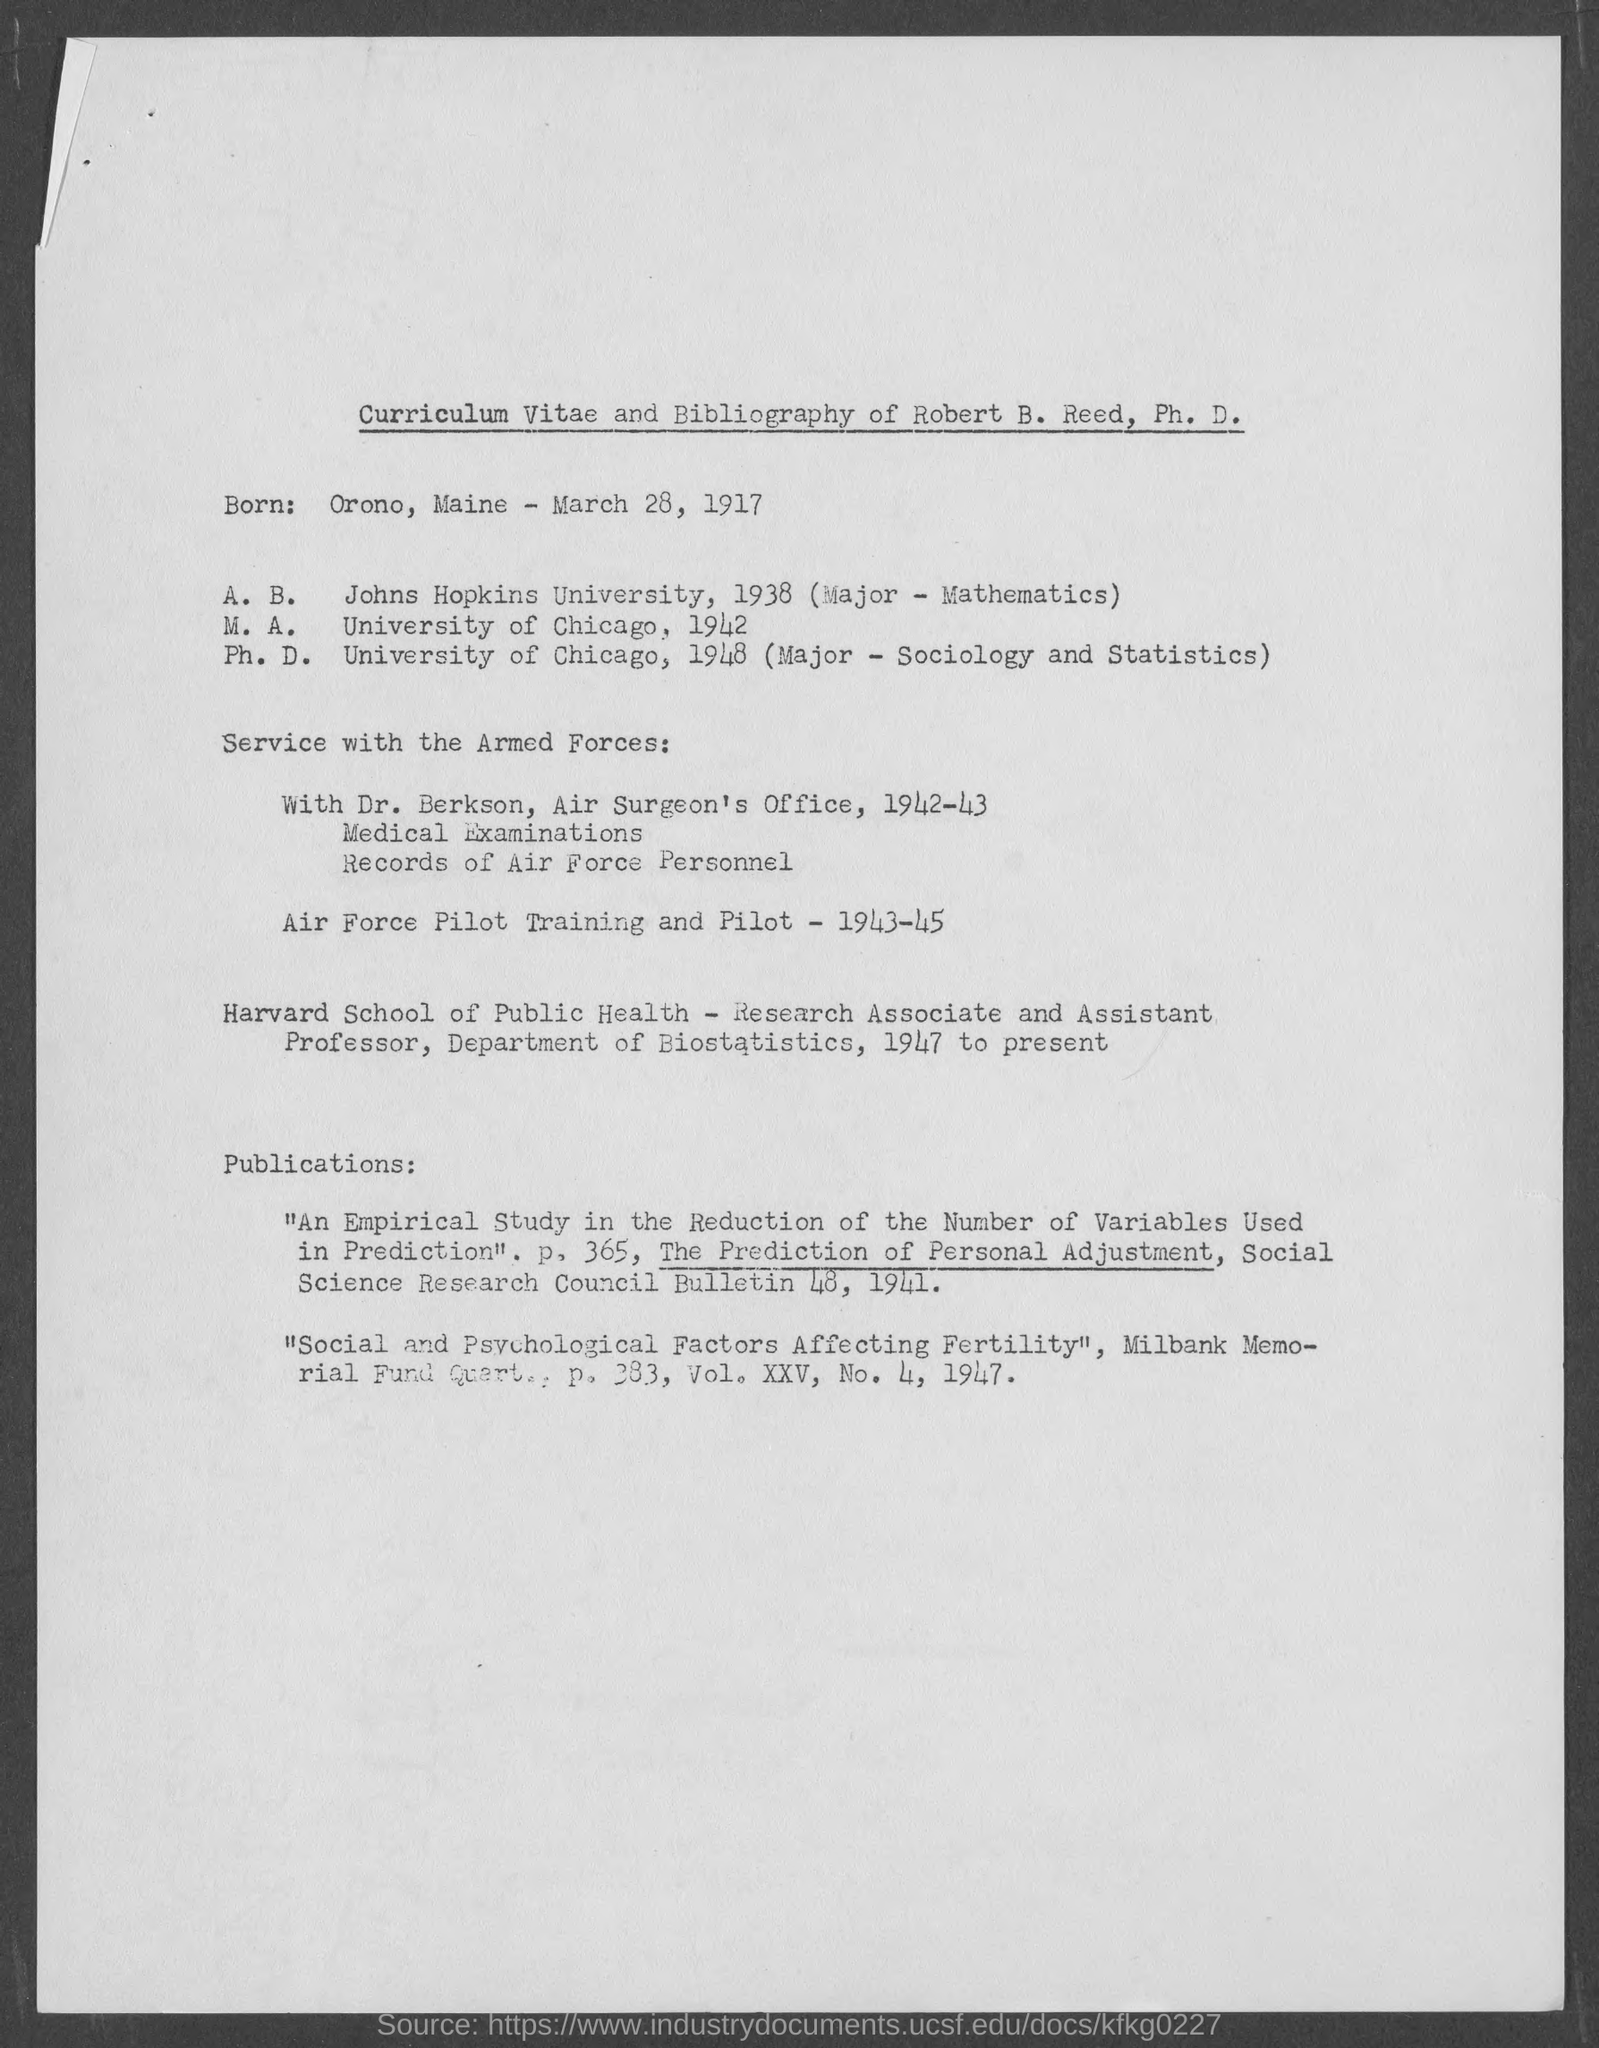What is the date of birth of robert b. reed, ph.d.?
Your answer should be very brief. March 28, 1917. What is place of birth of robert b. reed, ph.d.?
Make the answer very short. Orono, Maine. Where did robert b. reed complete his m.a. from?
Your answer should be compact. University of Chicago. When did robert b. reed complete his m.a?
Provide a succinct answer. 1942. Where did robert b. reed complete his ph.d. from?
Provide a short and direct response. University of Chicago. In which year did robert b. reed complete his ph.d.?
Offer a very short reply. 1948. What subjects did robert b. reed do his major in ph.d.?
Your answer should be compact. Sociology and Statistics. 